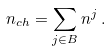Convert formula to latex. <formula><loc_0><loc_0><loc_500><loc_500>n _ { c h } = \sum _ { j \in B } n ^ { j } \, .</formula> 